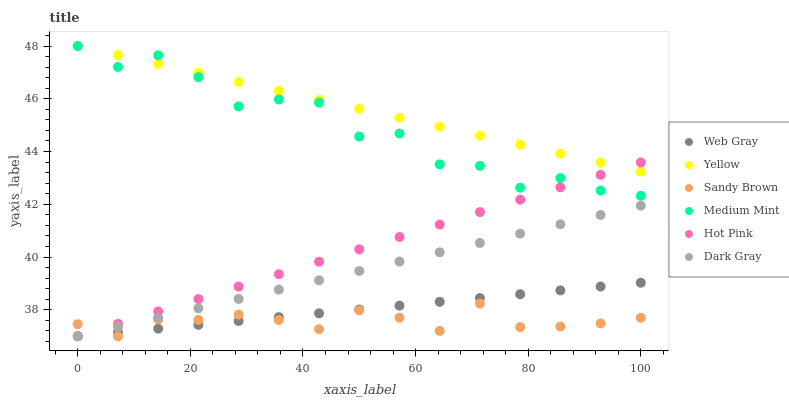Does Sandy Brown have the minimum area under the curve?
Answer yes or no. Yes. Does Yellow have the maximum area under the curve?
Answer yes or no. Yes. Does Web Gray have the minimum area under the curve?
Answer yes or no. No. Does Web Gray have the maximum area under the curve?
Answer yes or no. No. Is Web Gray the smoothest?
Answer yes or no. Yes. Is Medium Mint the roughest?
Answer yes or no. Yes. Is Hot Pink the smoothest?
Answer yes or no. No. Is Hot Pink the roughest?
Answer yes or no. No. Does Web Gray have the lowest value?
Answer yes or no. Yes. Does Yellow have the lowest value?
Answer yes or no. No. Does Yellow have the highest value?
Answer yes or no. Yes. Does Web Gray have the highest value?
Answer yes or no. No. Is Dark Gray less than Yellow?
Answer yes or no. Yes. Is Yellow greater than Dark Gray?
Answer yes or no. Yes. Does Web Gray intersect Hot Pink?
Answer yes or no. Yes. Is Web Gray less than Hot Pink?
Answer yes or no. No. Is Web Gray greater than Hot Pink?
Answer yes or no. No. Does Dark Gray intersect Yellow?
Answer yes or no. No. 